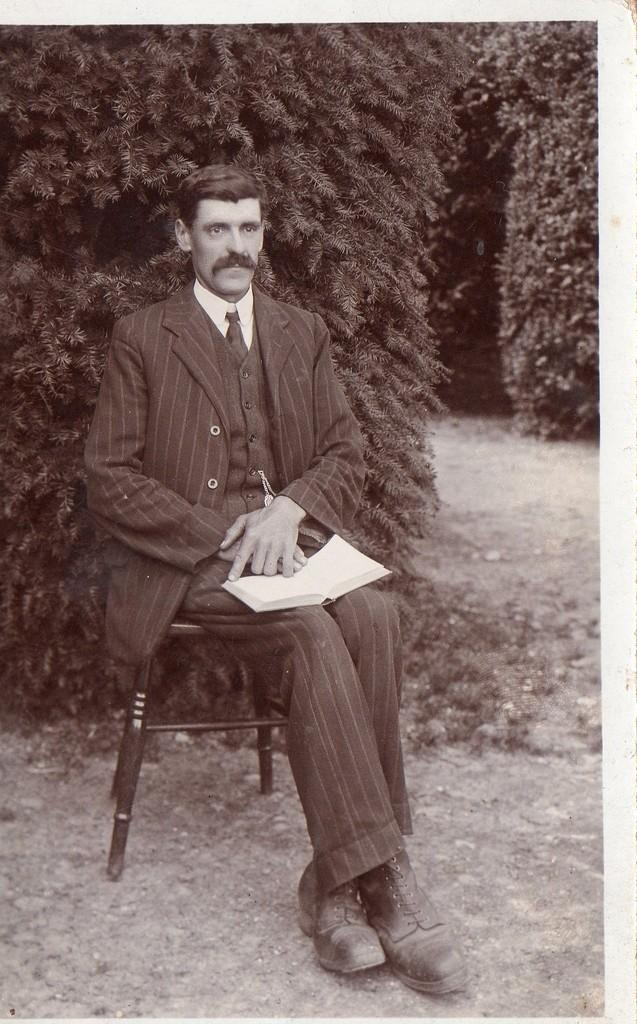What is the person in the image doing? The person is sitting in the image. What is the person holding? The person is holding a book. What can be seen in the background of the image? There are trees in the background of the image. What is the color scheme of the image? The image is in black and white. What type of poison is the person using to read the book in the image? There is no poison present in the image, and the person is not using any poison to read the book. 